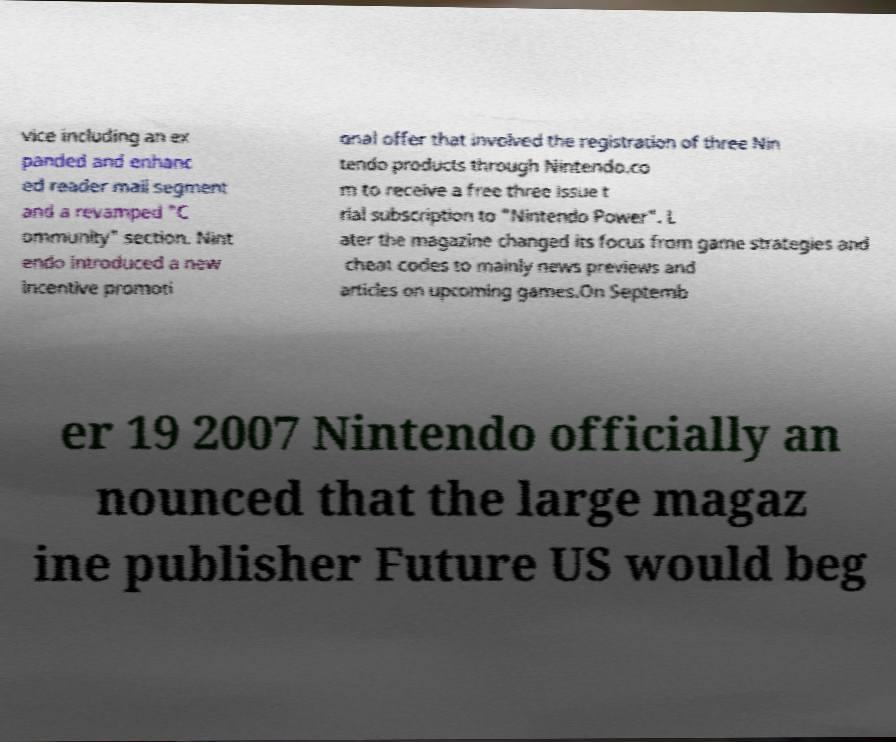Can you accurately transcribe the text from the provided image for me? vice including an ex panded and enhanc ed reader mail segment and a revamped "C ommunity" section. Nint endo introduced a new incentive promoti onal offer that involved the registration of three Nin tendo products through Nintendo.co m to receive a free three issue t rial subscription to "Nintendo Power". L ater the magazine changed its focus from game strategies and cheat codes to mainly news previews and articles on upcoming games.On Septemb er 19 2007 Nintendo officially an nounced that the large magaz ine publisher Future US would beg 